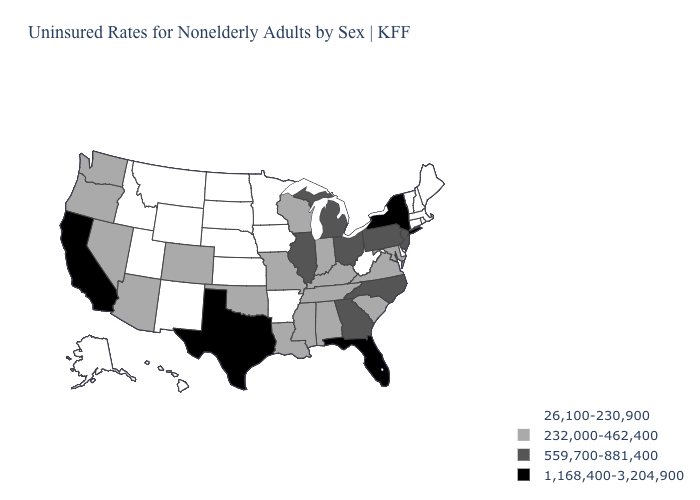Name the states that have a value in the range 559,700-881,400?
Give a very brief answer. Georgia, Illinois, Michigan, New Jersey, North Carolina, Ohio, Pennsylvania. What is the value of California?
Write a very short answer. 1,168,400-3,204,900. What is the value of Alabama?
Write a very short answer. 232,000-462,400. What is the lowest value in the Northeast?
Keep it brief. 26,100-230,900. Does the first symbol in the legend represent the smallest category?
Be succinct. Yes. What is the value of Wyoming?
Concise answer only. 26,100-230,900. What is the highest value in the West ?
Quick response, please. 1,168,400-3,204,900. What is the value of New York?
Give a very brief answer. 1,168,400-3,204,900. Does New Jersey have the lowest value in the Northeast?
Write a very short answer. No. What is the value of Iowa?
Keep it brief. 26,100-230,900. What is the highest value in the USA?
Quick response, please. 1,168,400-3,204,900. What is the value of Utah?
Give a very brief answer. 26,100-230,900. Name the states that have a value in the range 26,100-230,900?
Short answer required. Alaska, Arkansas, Connecticut, Delaware, Hawaii, Idaho, Iowa, Kansas, Maine, Massachusetts, Minnesota, Montana, Nebraska, New Hampshire, New Mexico, North Dakota, Rhode Island, South Dakota, Utah, Vermont, West Virginia, Wyoming. Does the first symbol in the legend represent the smallest category?
Concise answer only. Yes. What is the value of Tennessee?
Be succinct. 232,000-462,400. 